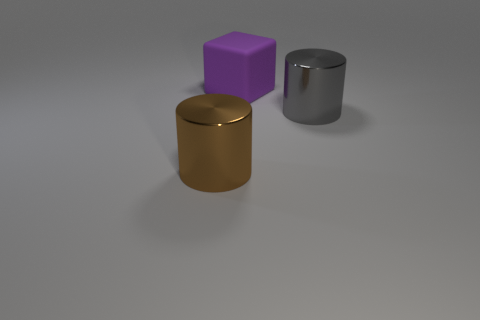Can you tell if the objects are arranged in a specific pattern or randomly? The objects in the image appear to be intentionally placed with even spacing on a flat surface. There does not seem to be an intricate pattern, but the arrangement is orderly – a gold cylinder, a purple cube, and a gray metallic cylinder, suggesting some level of deliberation in their positioning. 